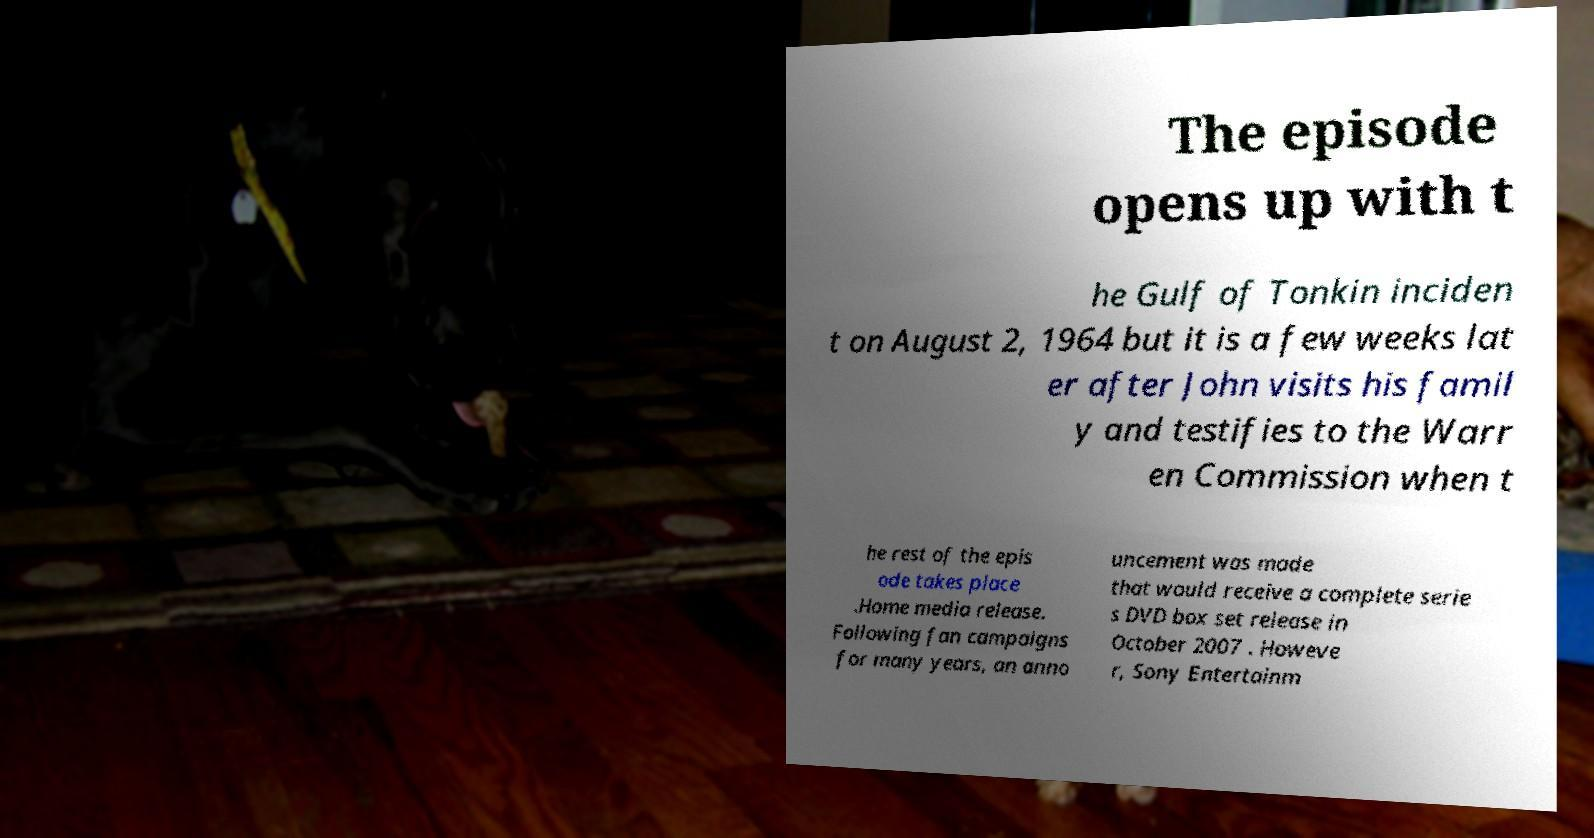For documentation purposes, I need the text within this image transcribed. Could you provide that? The episode opens up with t he Gulf of Tonkin inciden t on August 2, 1964 but it is a few weeks lat er after John visits his famil y and testifies to the Warr en Commission when t he rest of the epis ode takes place .Home media release. Following fan campaigns for many years, an anno uncement was made that would receive a complete serie s DVD box set release in October 2007 . Howeve r, Sony Entertainm 